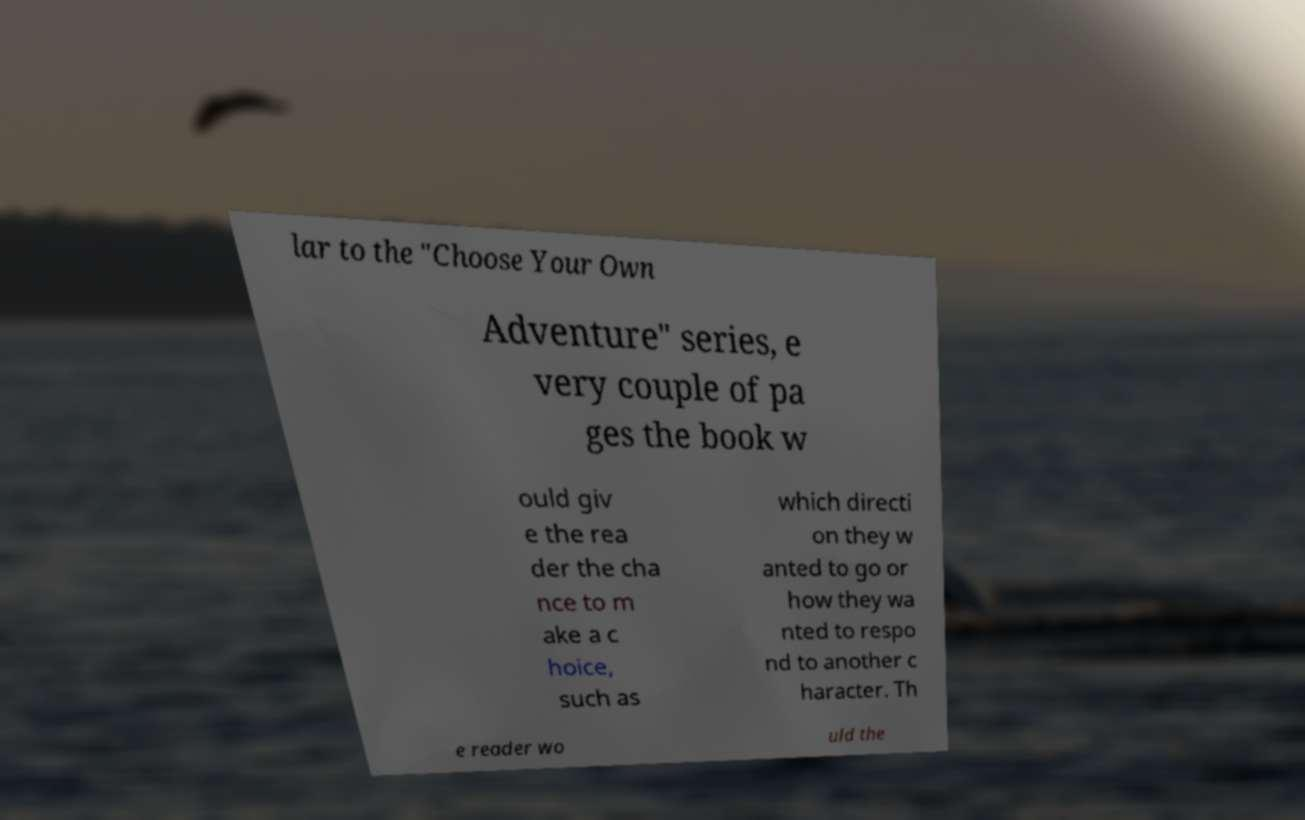I need the written content from this picture converted into text. Can you do that? lar to the "Choose Your Own Adventure" series, e very couple of pa ges the book w ould giv e the rea der the cha nce to m ake a c hoice, such as which directi on they w anted to go or how they wa nted to respo nd to another c haracter. Th e reader wo uld the 